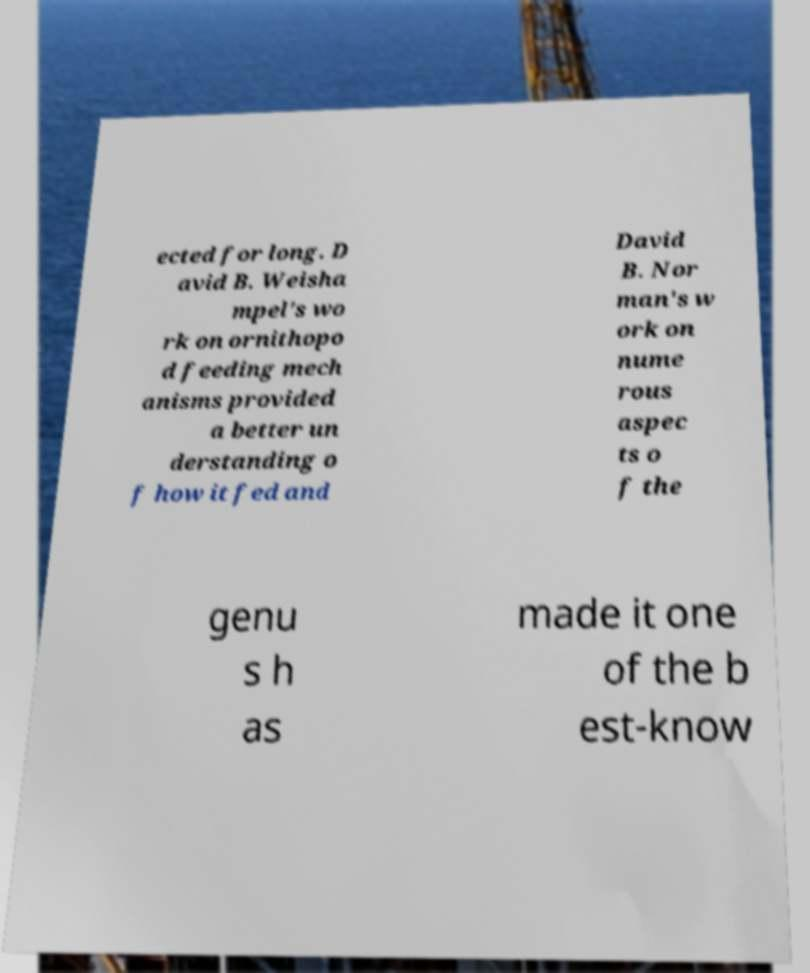Could you assist in decoding the text presented in this image and type it out clearly? ected for long. D avid B. Weisha mpel's wo rk on ornithopo d feeding mech anisms provided a better un derstanding o f how it fed and David B. Nor man's w ork on nume rous aspec ts o f the genu s h as made it one of the b est-know 